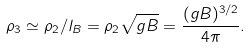Convert formula to latex. <formula><loc_0><loc_0><loc_500><loc_500>\rho _ { 3 } \simeq \rho _ { 2 } / l _ { B } = \rho _ { 2 } \sqrt { g B } = \frac { ( g B ) ^ { 3 / 2 } } { 4 \pi } .</formula> 